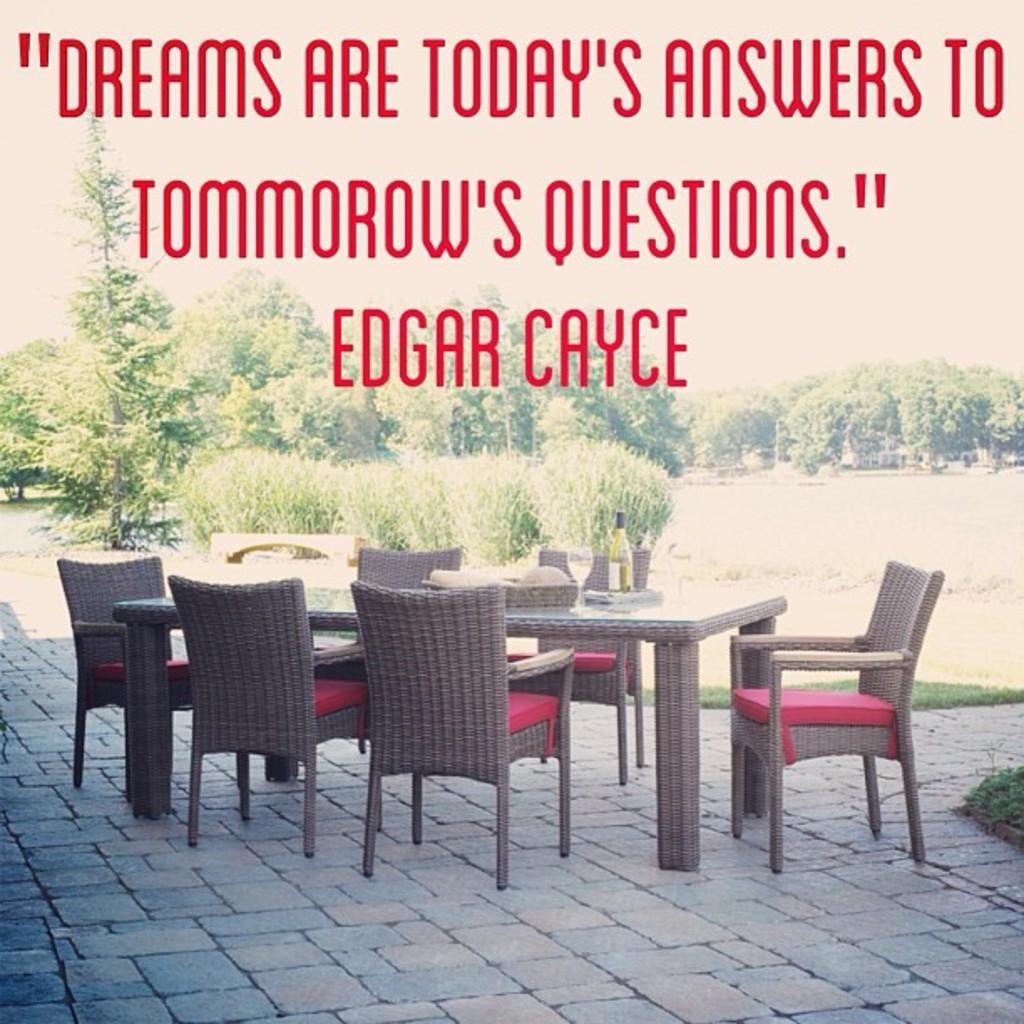How would you summarize this image in a sentence or two? In the picture we can see a table on the path and near it, we can see some chairs and behind it, we can see a grass surface on it, we can see some plants, trees, and written on it as Dreams are today's answers to tomorrow's questions. 